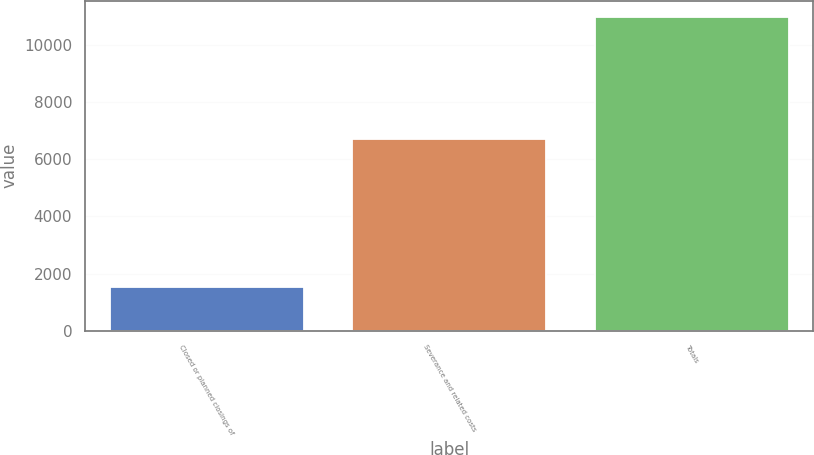Convert chart. <chart><loc_0><loc_0><loc_500><loc_500><bar_chart><fcel>Closed or planned closings of<fcel>Severance and related costs<fcel>Totals<nl><fcel>1512<fcel>6715<fcel>10993<nl></chart> 